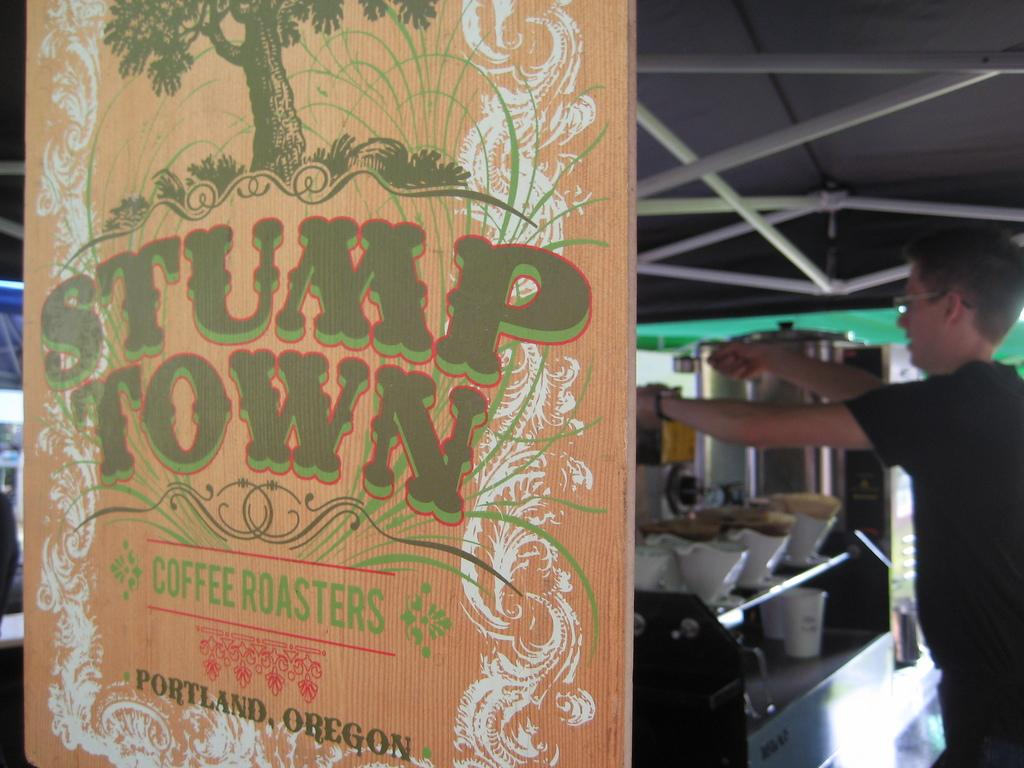<image>
Offer a succinct explanation of the picture presented. An artistic sign display for Stump Town coffee roasters confirms there Portland Oregon origins. 